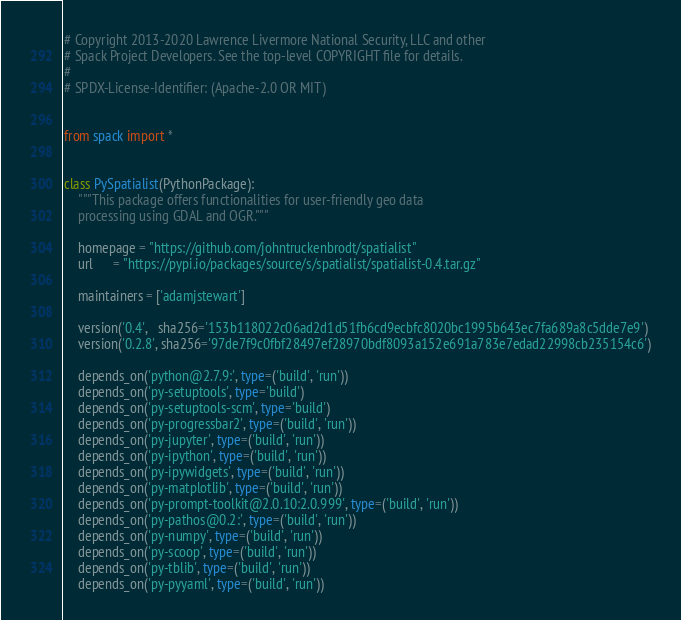<code> <loc_0><loc_0><loc_500><loc_500><_Python_># Copyright 2013-2020 Lawrence Livermore National Security, LLC and other
# Spack Project Developers. See the top-level COPYRIGHT file for details.
#
# SPDX-License-Identifier: (Apache-2.0 OR MIT)


from spack import *


class PySpatialist(PythonPackage):
    """This package offers functionalities for user-friendly geo data
    processing using GDAL and OGR."""

    homepage = "https://github.com/johntruckenbrodt/spatialist"
    url      = "https://pypi.io/packages/source/s/spatialist/spatialist-0.4.tar.gz"

    maintainers = ['adamjstewart']

    version('0.4',   sha256='153b118022c06ad2d1d51fb6cd9ecbfc8020bc1995b643ec7fa689a8c5dde7e9')
    version('0.2.8', sha256='97de7f9c0fbf28497ef28970bdf8093a152e691a783e7edad22998cb235154c6')

    depends_on('python@2.7.9:', type=('build', 'run'))
    depends_on('py-setuptools', type='build')
    depends_on('py-setuptools-scm', type='build')
    depends_on('py-progressbar2', type=('build', 'run'))
    depends_on('py-jupyter', type=('build', 'run'))
    depends_on('py-ipython', type=('build', 'run'))
    depends_on('py-ipywidgets', type=('build', 'run'))
    depends_on('py-matplotlib', type=('build', 'run'))
    depends_on('py-prompt-toolkit@2.0.10:2.0.999', type=('build', 'run'))
    depends_on('py-pathos@0.2:', type=('build', 'run'))
    depends_on('py-numpy', type=('build', 'run'))
    depends_on('py-scoop', type=('build', 'run'))
    depends_on('py-tblib', type=('build', 'run'))
    depends_on('py-pyyaml', type=('build', 'run'))
</code> 